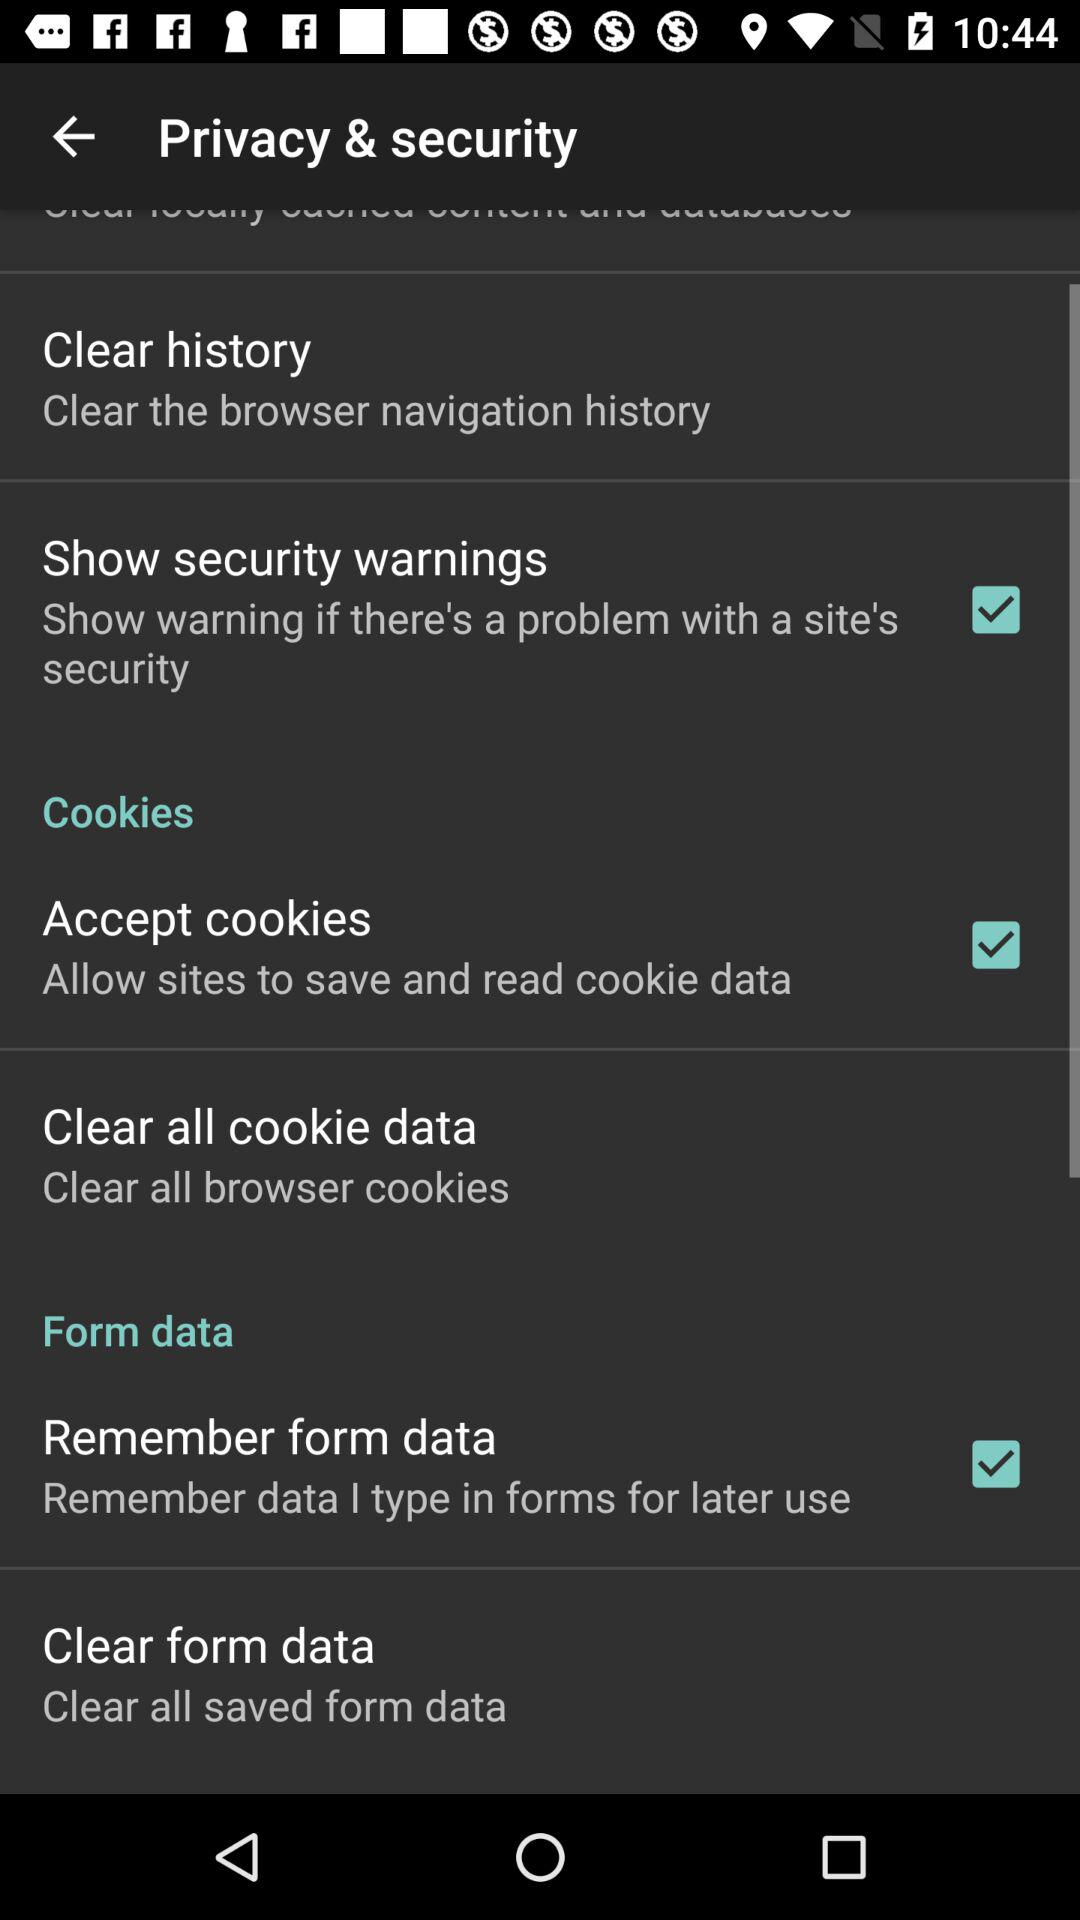What is the status of "Show security warnings"? The status is "on". 